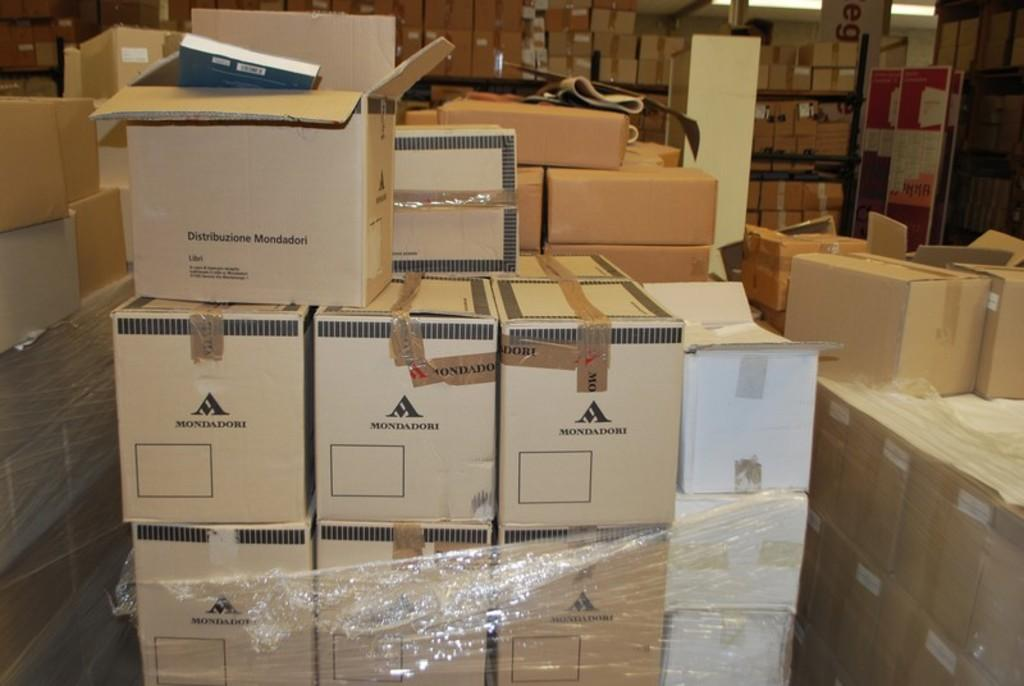<image>
Offer a succinct explanation of the picture presented. A pile of boxes that say Mandadori are in a warehouse. 